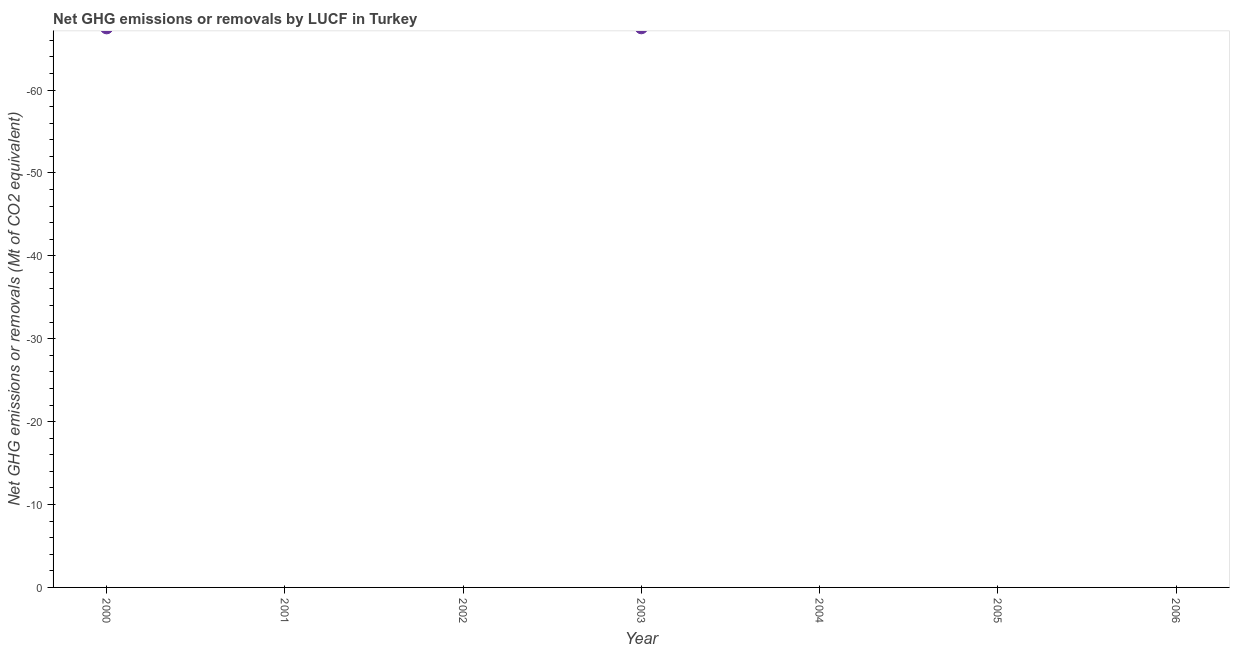What is the ghg net emissions or removals in 2001?
Provide a short and direct response. 0. Across all years, what is the minimum ghg net emissions or removals?
Offer a very short reply. 0. What is the sum of the ghg net emissions or removals?
Ensure brevity in your answer.  0. What is the median ghg net emissions or removals?
Your answer should be very brief. 0. In how many years, is the ghg net emissions or removals greater than -16 Mt?
Offer a very short reply. 0. In how many years, is the ghg net emissions or removals greater than the average ghg net emissions or removals taken over all years?
Make the answer very short. 0. Are the values on the major ticks of Y-axis written in scientific E-notation?
Your answer should be very brief. No. Does the graph contain any zero values?
Your answer should be very brief. Yes. Does the graph contain grids?
Your answer should be compact. No. What is the title of the graph?
Provide a short and direct response. Net GHG emissions or removals by LUCF in Turkey. What is the label or title of the X-axis?
Your response must be concise. Year. What is the label or title of the Y-axis?
Provide a short and direct response. Net GHG emissions or removals (Mt of CO2 equivalent). What is the Net GHG emissions or removals (Mt of CO2 equivalent) in 2000?
Provide a succinct answer. 0. What is the Net GHG emissions or removals (Mt of CO2 equivalent) in 2005?
Provide a short and direct response. 0. What is the Net GHG emissions or removals (Mt of CO2 equivalent) in 2006?
Your response must be concise. 0. 